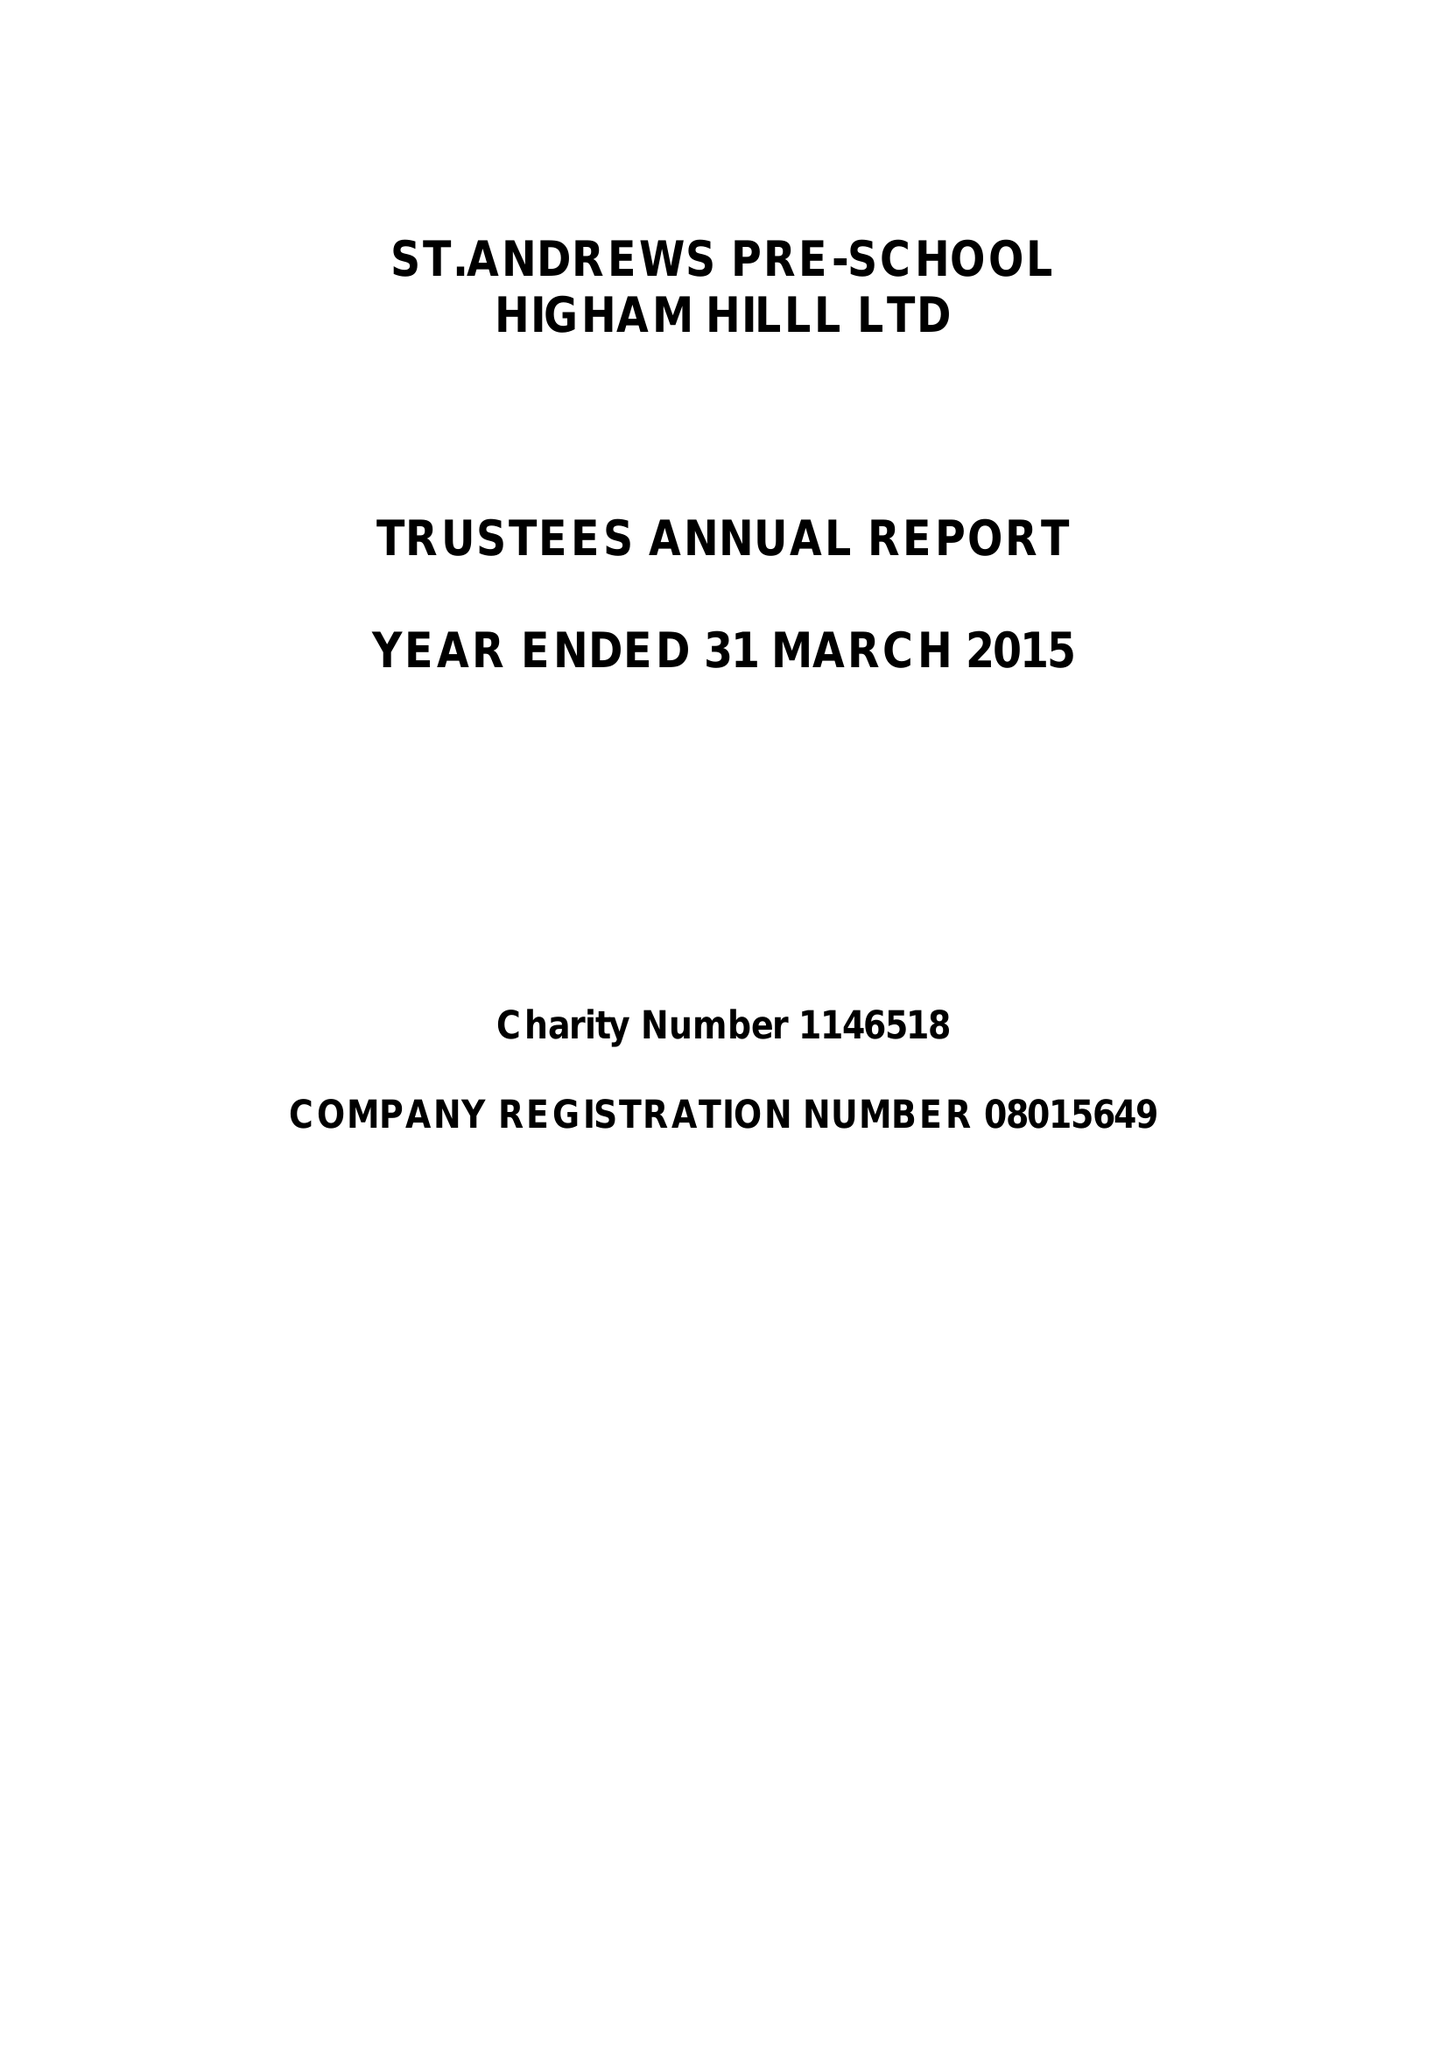What is the value for the address__street_line?
Answer the question using a single word or phrase. CHURCH ROAD 